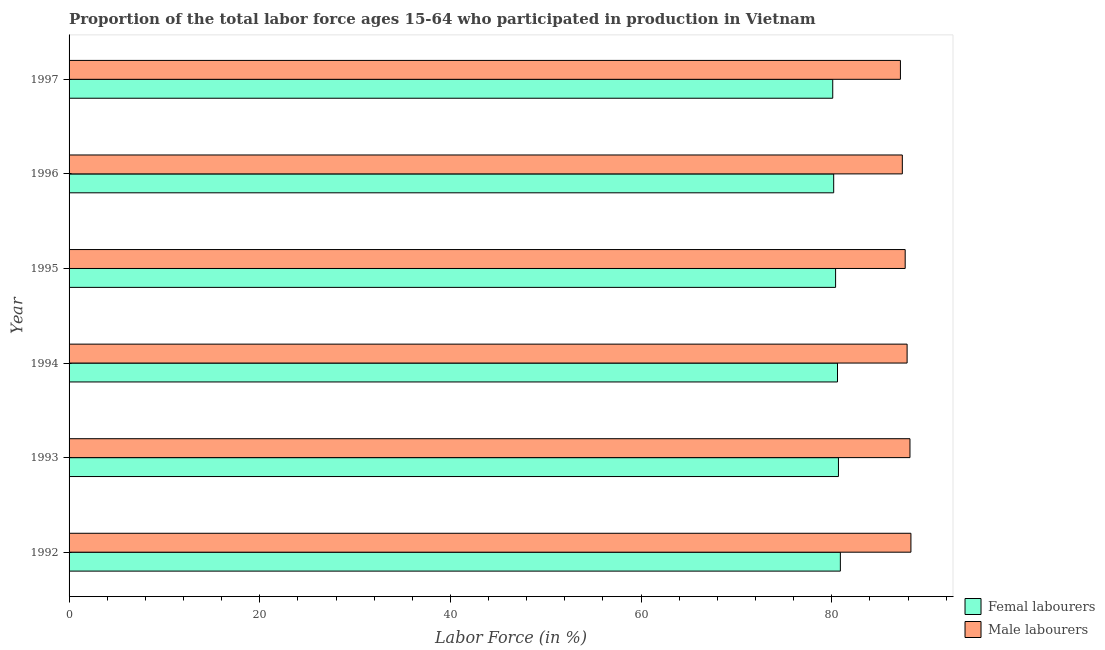How many different coloured bars are there?
Your response must be concise. 2. How many groups of bars are there?
Provide a succinct answer. 6. Are the number of bars per tick equal to the number of legend labels?
Your answer should be compact. Yes. How many bars are there on the 2nd tick from the bottom?
Ensure brevity in your answer.  2. In how many cases, is the number of bars for a given year not equal to the number of legend labels?
Keep it short and to the point. 0. What is the percentage of male labour force in 1993?
Your response must be concise. 88.2. Across all years, what is the maximum percentage of female labor force?
Provide a short and direct response. 80.9. Across all years, what is the minimum percentage of female labor force?
Ensure brevity in your answer.  80.1. In which year was the percentage of female labor force minimum?
Offer a very short reply. 1997. What is the total percentage of female labor force in the graph?
Ensure brevity in your answer.  482.9. What is the difference between the percentage of male labour force in 1993 and the percentage of female labor force in 1997?
Your response must be concise. 8.1. What is the average percentage of male labour force per year?
Provide a succinct answer. 87.78. In how many years, is the percentage of male labour force greater than 72 %?
Give a very brief answer. 6. What is the ratio of the percentage of male labour force in 1992 to that in 1993?
Give a very brief answer. 1. What is the difference between the highest and the second highest percentage of female labor force?
Your response must be concise. 0.2. What is the difference between the highest and the lowest percentage of female labor force?
Ensure brevity in your answer.  0.8. What does the 2nd bar from the top in 1993 represents?
Your answer should be very brief. Femal labourers. What does the 2nd bar from the bottom in 1992 represents?
Provide a short and direct response. Male labourers. Are the values on the major ticks of X-axis written in scientific E-notation?
Make the answer very short. No. Does the graph contain any zero values?
Offer a terse response. No. What is the title of the graph?
Keep it short and to the point. Proportion of the total labor force ages 15-64 who participated in production in Vietnam. Does "Grants" appear as one of the legend labels in the graph?
Provide a short and direct response. No. What is the Labor Force (in %) of Femal labourers in 1992?
Offer a very short reply. 80.9. What is the Labor Force (in %) of Male labourers in 1992?
Offer a very short reply. 88.3. What is the Labor Force (in %) in Femal labourers in 1993?
Your answer should be very brief. 80.7. What is the Labor Force (in %) of Male labourers in 1993?
Offer a terse response. 88.2. What is the Labor Force (in %) in Femal labourers in 1994?
Provide a short and direct response. 80.6. What is the Labor Force (in %) of Male labourers in 1994?
Your answer should be compact. 87.9. What is the Labor Force (in %) of Femal labourers in 1995?
Your answer should be compact. 80.4. What is the Labor Force (in %) in Male labourers in 1995?
Your response must be concise. 87.7. What is the Labor Force (in %) in Femal labourers in 1996?
Keep it short and to the point. 80.2. What is the Labor Force (in %) of Male labourers in 1996?
Ensure brevity in your answer.  87.4. What is the Labor Force (in %) of Femal labourers in 1997?
Keep it short and to the point. 80.1. What is the Labor Force (in %) in Male labourers in 1997?
Ensure brevity in your answer.  87.2. Across all years, what is the maximum Labor Force (in %) in Femal labourers?
Give a very brief answer. 80.9. Across all years, what is the maximum Labor Force (in %) of Male labourers?
Give a very brief answer. 88.3. Across all years, what is the minimum Labor Force (in %) in Femal labourers?
Provide a succinct answer. 80.1. Across all years, what is the minimum Labor Force (in %) of Male labourers?
Give a very brief answer. 87.2. What is the total Labor Force (in %) in Femal labourers in the graph?
Make the answer very short. 482.9. What is the total Labor Force (in %) of Male labourers in the graph?
Make the answer very short. 526.7. What is the difference between the Labor Force (in %) in Femal labourers in 1992 and that in 1993?
Provide a short and direct response. 0.2. What is the difference between the Labor Force (in %) of Femal labourers in 1992 and that in 1994?
Your answer should be very brief. 0.3. What is the difference between the Labor Force (in %) of Femal labourers in 1992 and that in 1996?
Your answer should be very brief. 0.7. What is the difference between the Labor Force (in %) of Male labourers in 1992 and that in 1997?
Ensure brevity in your answer.  1.1. What is the difference between the Labor Force (in %) in Femal labourers in 1993 and that in 1994?
Make the answer very short. 0.1. What is the difference between the Labor Force (in %) in Male labourers in 1993 and that in 1995?
Offer a terse response. 0.5. What is the difference between the Labor Force (in %) in Femal labourers in 1993 and that in 1996?
Make the answer very short. 0.5. What is the difference between the Labor Force (in %) of Male labourers in 1993 and that in 1996?
Keep it short and to the point. 0.8. What is the difference between the Labor Force (in %) of Femal labourers in 1993 and that in 1997?
Keep it short and to the point. 0.6. What is the difference between the Labor Force (in %) in Male labourers in 1993 and that in 1997?
Offer a terse response. 1. What is the difference between the Labor Force (in %) in Femal labourers in 1994 and that in 1995?
Provide a short and direct response. 0.2. What is the difference between the Labor Force (in %) of Male labourers in 1994 and that in 1995?
Your response must be concise. 0.2. What is the difference between the Labor Force (in %) in Femal labourers in 1994 and that in 1996?
Keep it short and to the point. 0.4. What is the difference between the Labor Force (in %) in Femal labourers in 1994 and that in 1997?
Make the answer very short. 0.5. What is the difference between the Labor Force (in %) of Femal labourers in 1995 and that in 1996?
Ensure brevity in your answer.  0.2. What is the difference between the Labor Force (in %) of Male labourers in 1995 and that in 1996?
Offer a very short reply. 0.3. What is the difference between the Labor Force (in %) in Femal labourers in 1995 and that in 1997?
Your response must be concise. 0.3. What is the difference between the Labor Force (in %) of Femal labourers in 1992 and the Labor Force (in %) of Male labourers in 1995?
Give a very brief answer. -6.8. What is the difference between the Labor Force (in %) of Femal labourers in 1993 and the Labor Force (in %) of Male labourers in 1996?
Provide a succinct answer. -6.7. What is the difference between the Labor Force (in %) of Femal labourers in 1993 and the Labor Force (in %) of Male labourers in 1997?
Your answer should be very brief. -6.5. What is the difference between the Labor Force (in %) in Femal labourers in 1994 and the Labor Force (in %) in Male labourers in 1997?
Your answer should be very brief. -6.6. What is the difference between the Labor Force (in %) of Femal labourers in 1995 and the Labor Force (in %) of Male labourers in 1996?
Offer a very short reply. -7. What is the difference between the Labor Force (in %) in Femal labourers in 1995 and the Labor Force (in %) in Male labourers in 1997?
Give a very brief answer. -6.8. What is the average Labor Force (in %) of Femal labourers per year?
Provide a short and direct response. 80.48. What is the average Labor Force (in %) in Male labourers per year?
Ensure brevity in your answer.  87.78. In the year 1993, what is the difference between the Labor Force (in %) of Femal labourers and Labor Force (in %) of Male labourers?
Your response must be concise. -7.5. In the year 1996, what is the difference between the Labor Force (in %) in Femal labourers and Labor Force (in %) in Male labourers?
Your answer should be compact. -7.2. What is the ratio of the Labor Force (in %) of Male labourers in 1992 to that in 1995?
Ensure brevity in your answer.  1.01. What is the ratio of the Labor Force (in %) of Femal labourers in 1992 to that in 1996?
Your answer should be compact. 1.01. What is the ratio of the Labor Force (in %) of Male labourers in 1992 to that in 1996?
Ensure brevity in your answer.  1.01. What is the ratio of the Labor Force (in %) of Male labourers in 1992 to that in 1997?
Provide a short and direct response. 1.01. What is the ratio of the Labor Force (in %) in Femal labourers in 1993 to that in 1994?
Provide a short and direct response. 1. What is the ratio of the Labor Force (in %) in Male labourers in 1993 to that in 1994?
Ensure brevity in your answer.  1. What is the ratio of the Labor Force (in %) in Femal labourers in 1993 to that in 1995?
Offer a terse response. 1. What is the ratio of the Labor Force (in %) in Male labourers in 1993 to that in 1995?
Keep it short and to the point. 1.01. What is the ratio of the Labor Force (in %) of Male labourers in 1993 to that in 1996?
Provide a succinct answer. 1.01. What is the ratio of the Labor Force (in %) of Femal labourers in 1993 to that in 1997?
Your response must be concise. 1.01. What is the ratio of the Labor Force (in %) of Male labourers in 1993 to that in 1997?
Your answer should be compact. 1.01. What is the ratio of the Labor Force (in %) in Male labourers in 1994 to that in 1995?
Ensure brevity in your answer.  1. What is the ratio of the Labor Force (in %) of Male labourers in 1994 to that in 1996?
Make the answer very short. 1.01. What is the ratio of the Labor Force (in %) of Femal labourers in 1994 to that in 1997?
Your answer should be compact. 1.01. What is the ratio of the Labor Force (in %) in Femal labourers in 1995 to that in 1997?
Offer a very short reply. 1. What is the ratio of the Labor Force (in %) of Male labourers in 1995 to that in 1997?
Provide a succinct answer. 1.01. What is the difference between the highest and the second highest Labor Force (in %) of Femal labourers?
Give a very brief answer. 0.2. What is the difference between the highest and the second highest Labor Force (in %) of Male labourers?
Your answer should be compact. 0.1. What is the difference between the highest and the lowest Labor Force (in %) in Femal labourers?
Give a very brief answer. 0.8. What is the difference between the highest and the lowest Labor Force (in %) in Male labourers?
Ensure brevity in your answer.  1.1. 